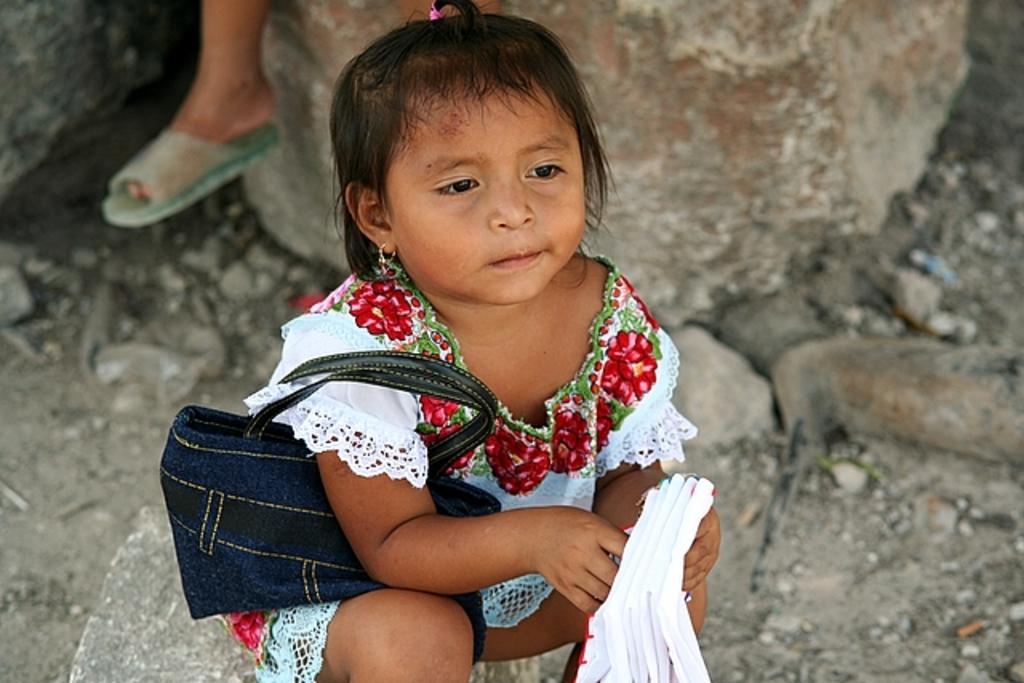Could you give a brief overview of what you see in this image? In the center of the picture there is a girl sitting wearing handbag and holding handkerchief. The background is blurred. In the background there are rocks and soil. On the left there is a person's leg. 